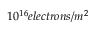<formula> <loc_0><loc_0><loc_500><loc_500>1 0 ^ { 1 6 } e l e c t r o n s / m ^ { 2 }</formula> 